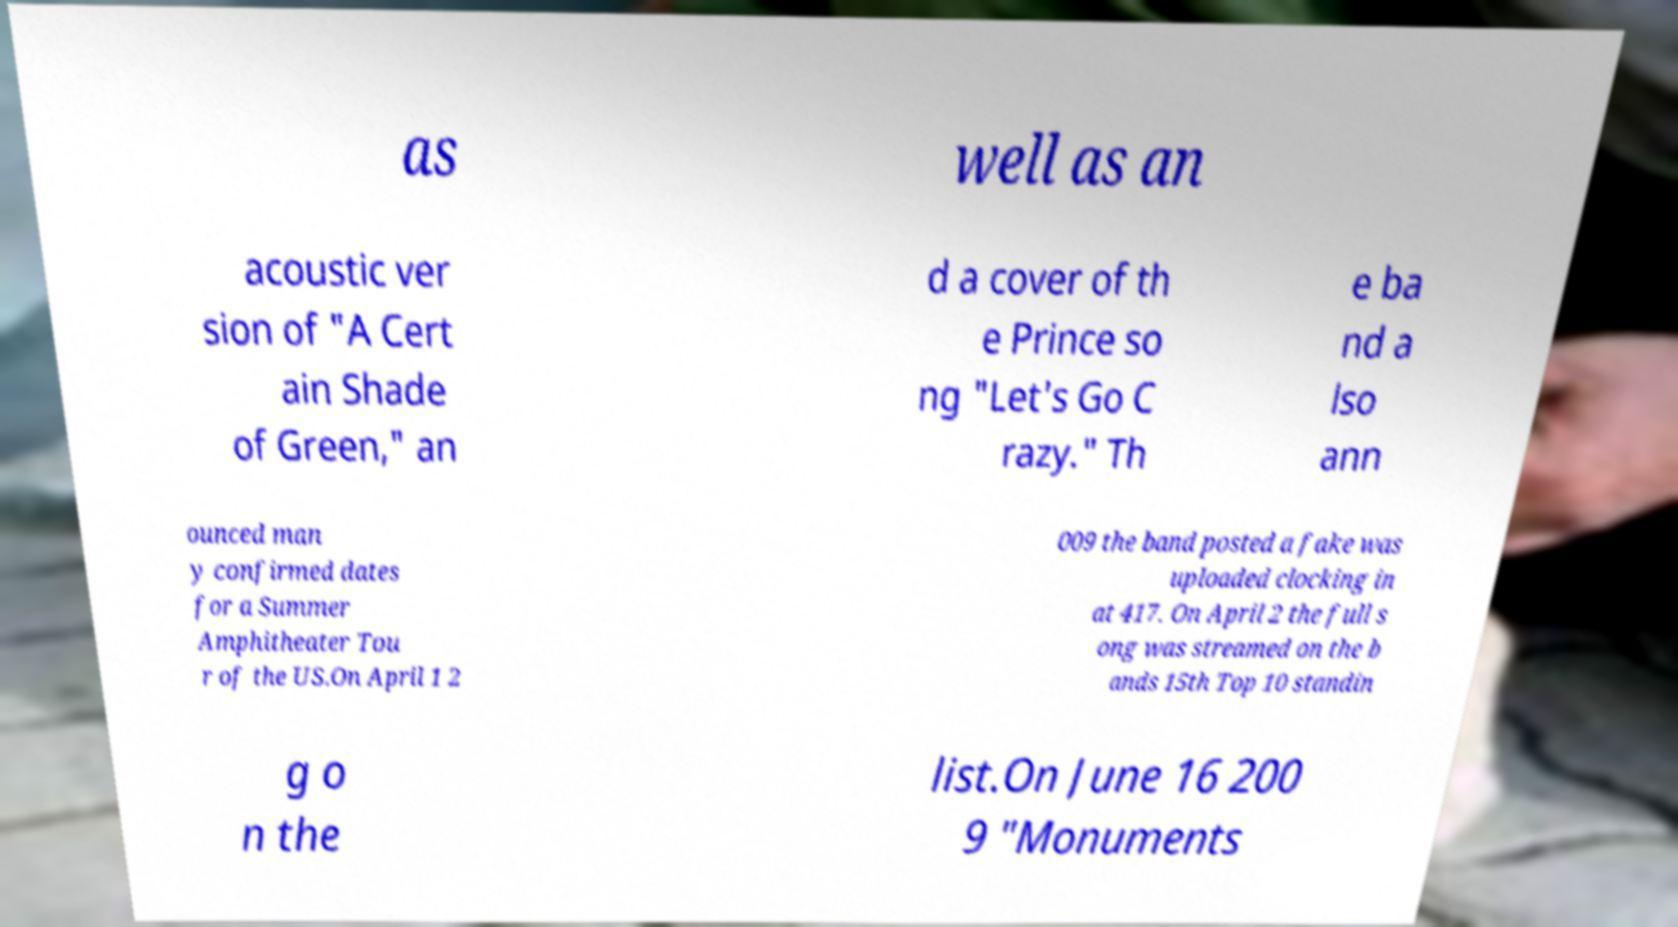There's text embedded in this image that I need extracted. Can you transcribe it verbatim? as well as an acoustic ver sion of "A Cert ain Shade of Green," an d a cover of th e Prince so ng "Let's Go C razy." Th e ba nd a lso ann ounced man y confirmed dates for a Summer Amphitheater Tou r of the US.On April 1 2 009 the band posted a fake was uploaded clocking in at 417. On April 2 the full s ong was streamed on the b ands 15th Top 10 standin g o n the list.On June 16 200 9 "Monuments 